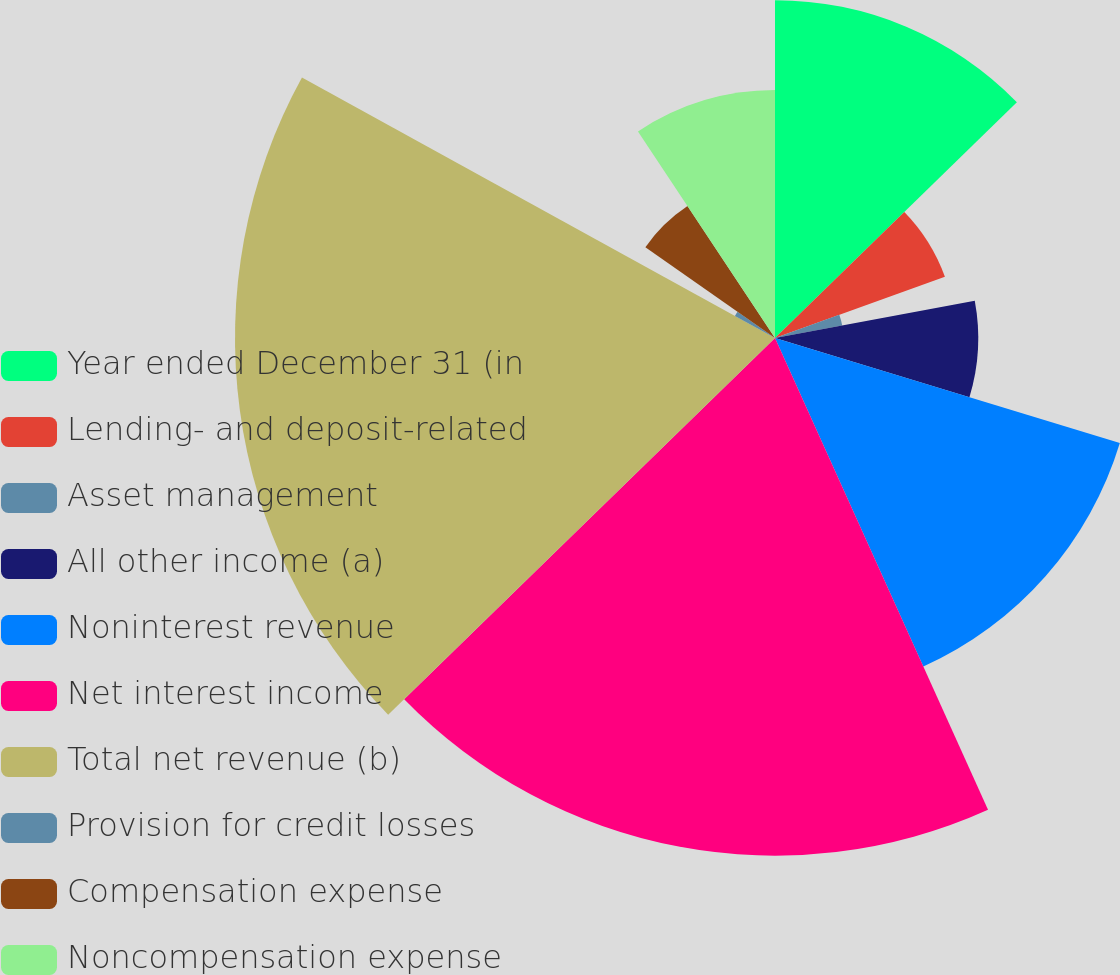<chart> <loc_0><loc_0><loc_500><loc_500><pie_chart><fcel>Year ended December 31 (in<fcel>Lending- and deposit-related<fcel>Asset management<fcel>All other income (a)<fcel>Noninterest revenue<fcel>Net interest income<fcel>Total net revenue (b)<fcel>Provision for credit losses<fcel>Compensation expense<fcel>Noncompensation expense<nl><fcel>12.7%<fcel>6.79%<fcel>2.57%<fcel>7.64%<fcel>13.55%<fcel>19.46%<fcel>20.3%<fcel>1.72%<fcel>5.95%<fcel>9.32%<nl></chart> 